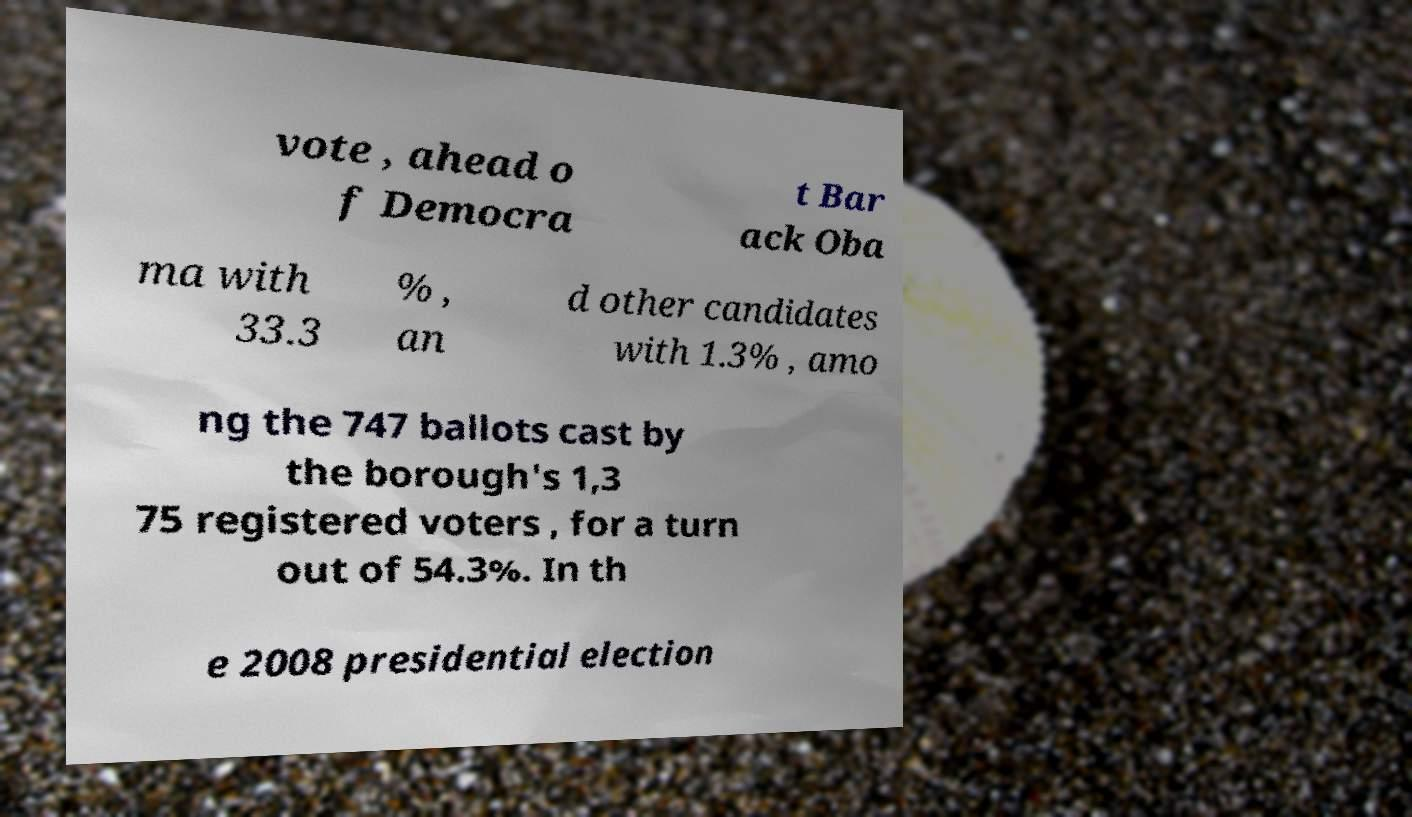What messages or text are displayed in this image? I need them in a readable, typed format. vote , ahead o f Democra t Bar ack Oba ma with 33.3 % , an d other candidates with 1.3% , amo ng the 747 ballots cast by the borough's 1,3 75 registered voters , for a turn out of 54.3%. In th e 2008 presidential election 